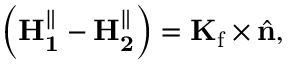Convert formula to latex. <formula><loc_0><loc_0><loc_500><loc_500>\left ( H _ { 1 } ^ { \| } - H _ { 2 } ^ { \| } \right ) = K _ { f } \times { \hat { n } } ,</formula> 